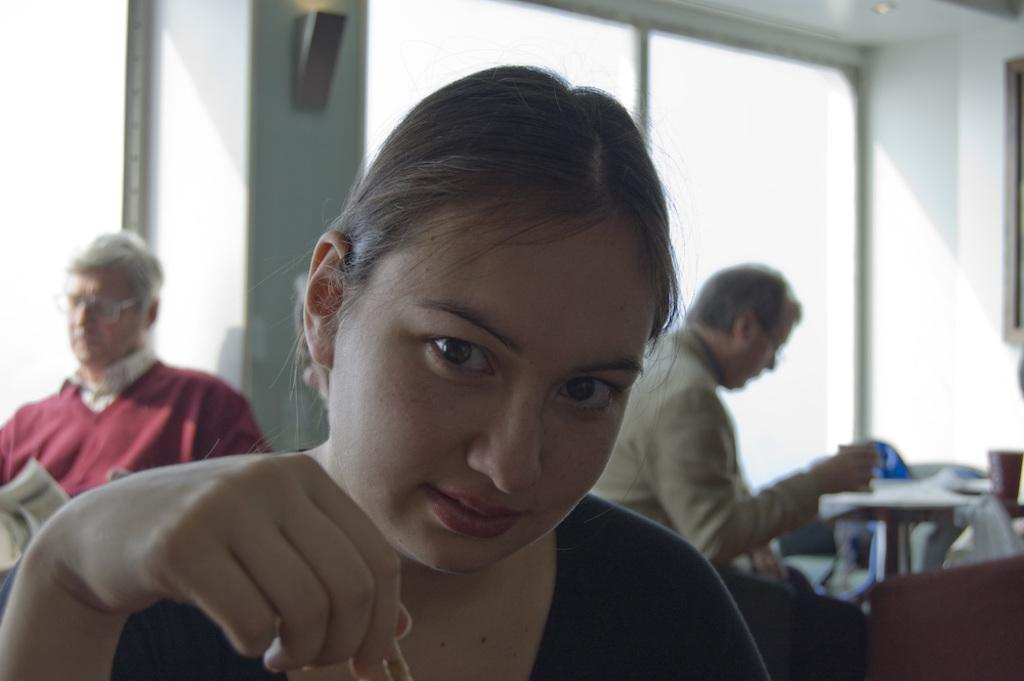Who is the main subject in the image? There is a woman in the image. What is the relationship between the woman and the two men behind her? The two men are sitting behind the woman, which might suggest they are in a meeting or conversation with her. What is the primary object in the image? There is a table in the image. What is on the table? There are objects on the table. What can be seen in the background of the image? There is a wall and glass visible in the background of the image. What type of hammer is the bee using to twist the glass in the image? There is no hammer, bee, or twisting of glass present in the image. 